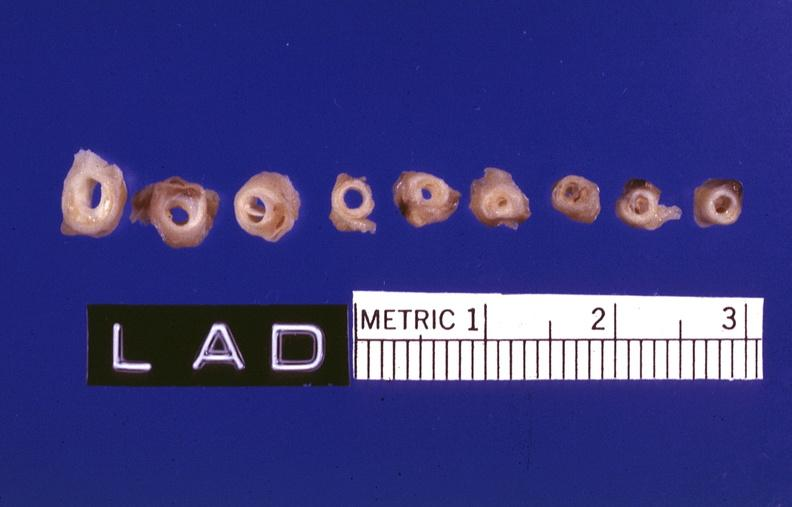does marfans syndrome show atherosclerosis?
Answer the question using a single word or phrase. No 